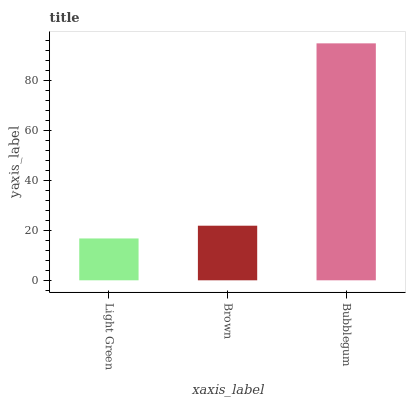Is Light Green the minimum?
Answer yes or no. Yes. Is Bubblegum the maximum?
Answer yes or no. Yes. Is Brown the minimum?
Answer yes or no. No. Is Brown the maximum?
Answer yes or no. No. Is Brown greater than Light Green?
Answer yes or no. Yes. Is Light Green less than Brown?
Answer yes or no. Yes. Is Light Green greater than Brown?
Answer yes or no. No. Is Brown less than Light Green?
Answer yes or no. No. Is Brown the high median?
Answer yes or no. Yes. Is Brown the low median?
Answer yes or no. Yes. Is Light Green the high median?
Answer yes or no. No. Is Light Green the low median?
Answer yes or no. No. 